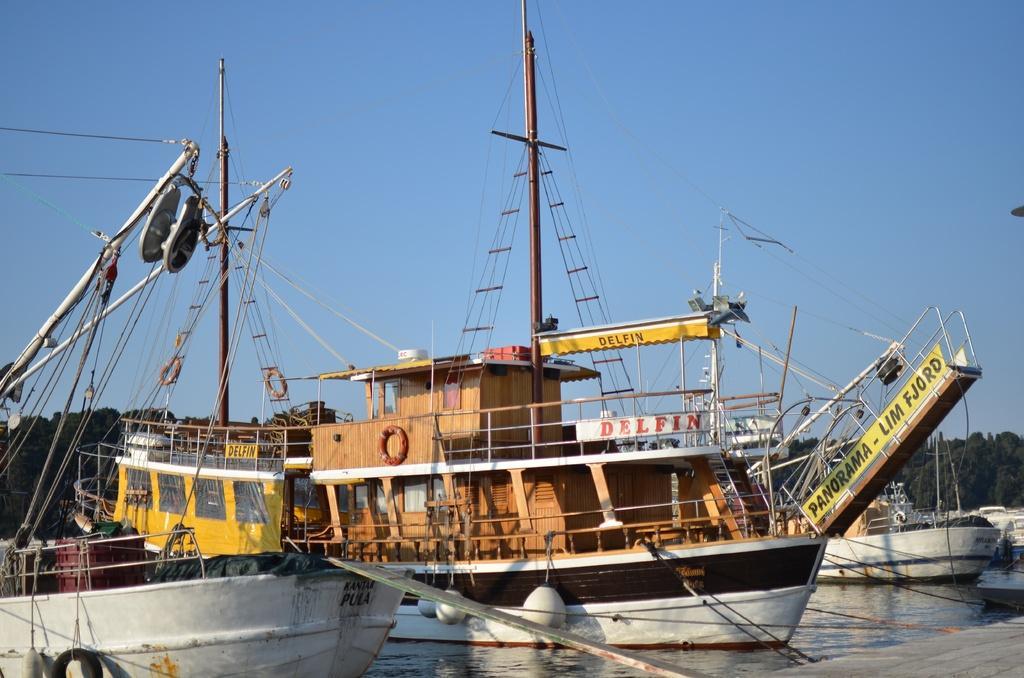Describe this image in one or two sentences. In this picture there are ships on the water and there are trees in the background area of the image. 